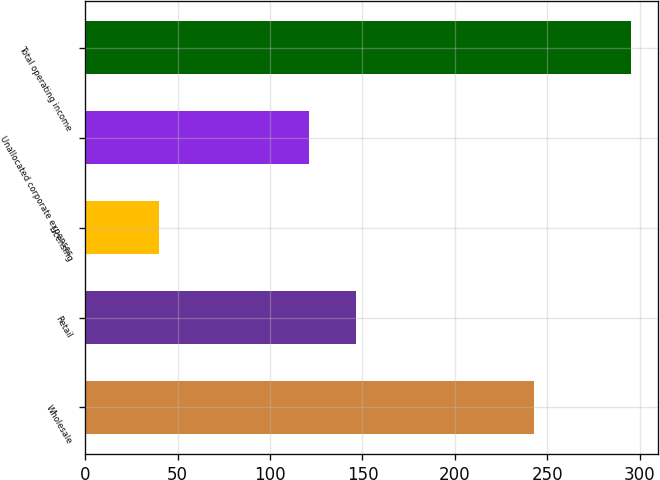<chart> <loc_0><loc_0><loc_500><loc_500><bar_chart><fcel>Wholesale<fcel>Retail<fcel>Licensing<fcel>Unallocated corporate expenses<fcel>Total operating income<nl><fcel>243<fcel>146.5<fcel>40<fcel>121<fcel>295<nl></chart> 